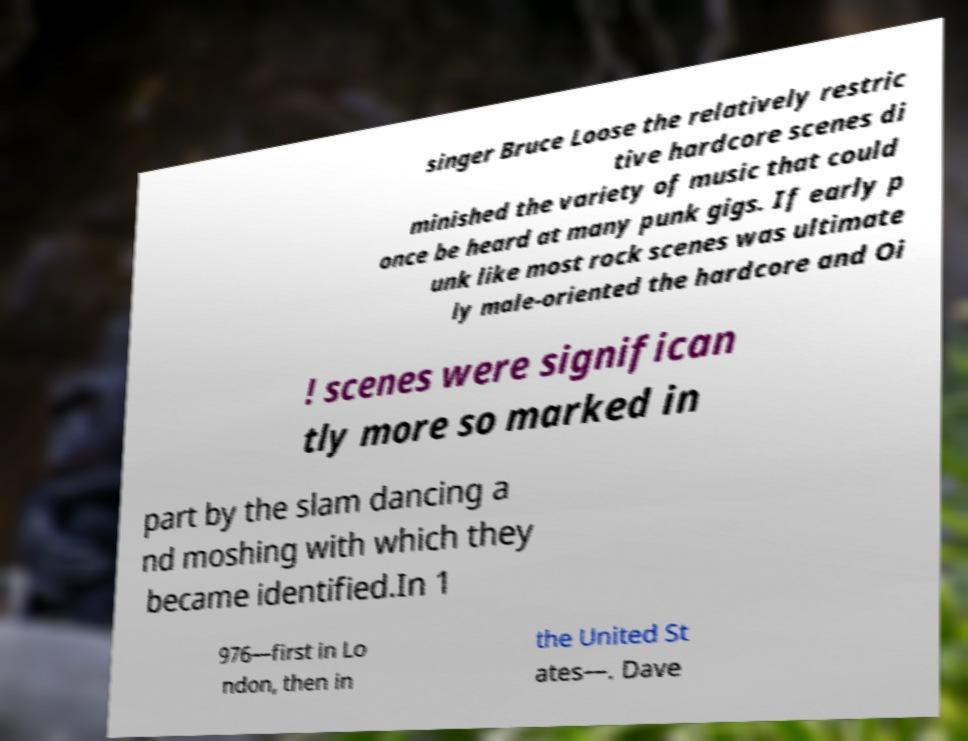I need the written content from this picture converted into text. Can you do that? singer Bruce Loose the relatively restric tive hardcore scenes di minished the variety of music that could once be heard at many punk gigs. If early p unk like most rock scenes was ultimate ly male-oriented the hardcore and Oi ! scenes were significan tly more so marked in part by the slam dancing a nd moshing with which they became identified.In 1 976—first in Lo ndon, then in the United St ates—. Dave 